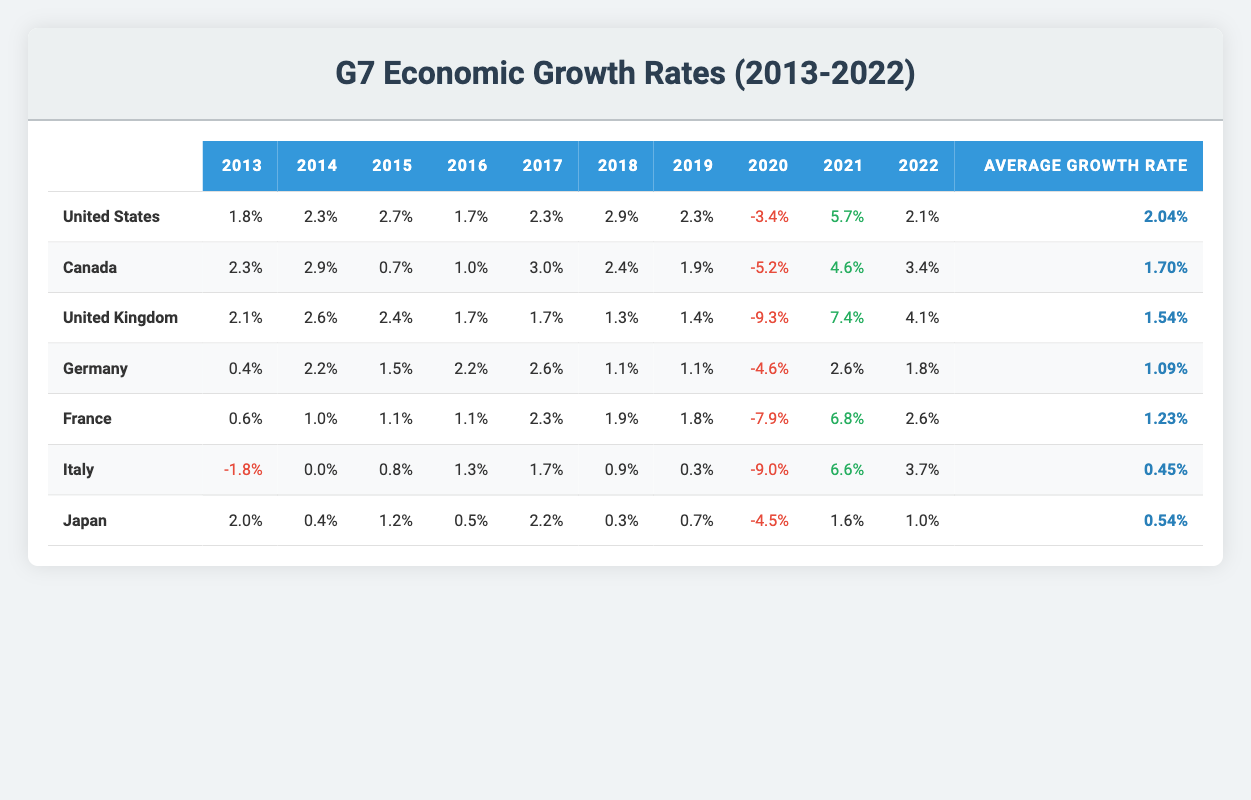What was the growth rate of Germany in 2014? In the table, locate the row for Germany and find the value in the 2014 column. The value for Germany in 2014 is 2.2.
Answer: 2.2 Which country had the highest average growth rate over the decade? To find the highest average growth rate, compare the "Average Growth Rate" values for all countries. The highest is for the United States at 2.04%.
Answer: United States Was Canada's growth rate in 2015 higher than Italy's growth rate in the same year? Check the growth rates listed for both countries in 2015. Canada's rate was 0.7%, while Italy's was 0.8%. Comparing these, 0.7% is less than 0.8%.
Answer: No What is the difference between the average growth rate of the United Kingdom and Japan? Calculate the average growth rates: United Kingdom = 1.54% and Japan = 0.54%. The difference is 1.54% - 0.54% = 1.00%.
Answer: 1.00 Did France experience a growth rate of more than 2% in 2019? Look at the 2019 growth rate for France in the table. France's growth rate for 2019 was 1.8%, which is less than 2%.
Answer: No Which G7 country had the lowest growth rate in 2020? Find the values in the 2020 column for all countries and identify the lowest. The lowest growth rate in 2020 was for the United Kingdom at -9.3%.
Answer: United Kingdom What was the growth rate for Canada in 2022 compared to its growth rate in 2013? Check the respective growth rates: Canada in 2022 was 3.4% and in 2013 was 2.3%. Comparing these, 3.4% is greater than 2.3%.
Answer: Yes Calculate the average of the growth rates in 2021 for the G7 countries mentioned in the table. Sum the growth rates for 2021: 5.7 + 4.6 + 7.4 + 2.6 + 6.8 + 6.6 + 1.6 = 35.3. Now, divide by the number of countries (7): 35.3/7 = 5.04%.
Answer: 5.04 How many G7 countries had negative growth rates in 2020? Count the entries in the 2020 column that are negative. The countries with negative growth rates in 2020 are the United States, Canada, United Kingdom, Germany, France, Italy, and Japan, totaling 6 countries.
Answer: 6 